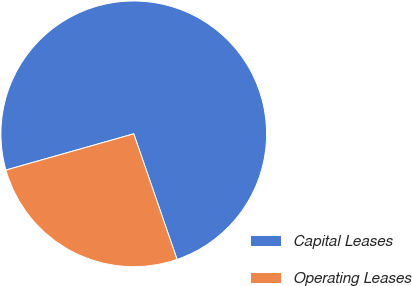<chart> <loc_0><loc_0><loc_500><loc_500><pie_chart><fcel>Capital Leases<fcel>Operating Leases<nl><fcel>74.11%<fcel>25.89%<nl></chart> 